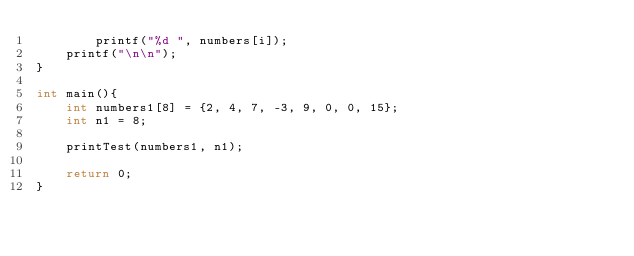<code> <loc_0><loc_0><loc_500><loc_500><_C_>        printf("%d ", numbers[i]);
    printf("\n\n");
}

int main(){
    int numbers1[8] = {2, 4, 7, -3, 9, 0, 0, 15};
    int n1 = 8;
    
    printTest(numbers1, n1);

    return 0;
}</code> 